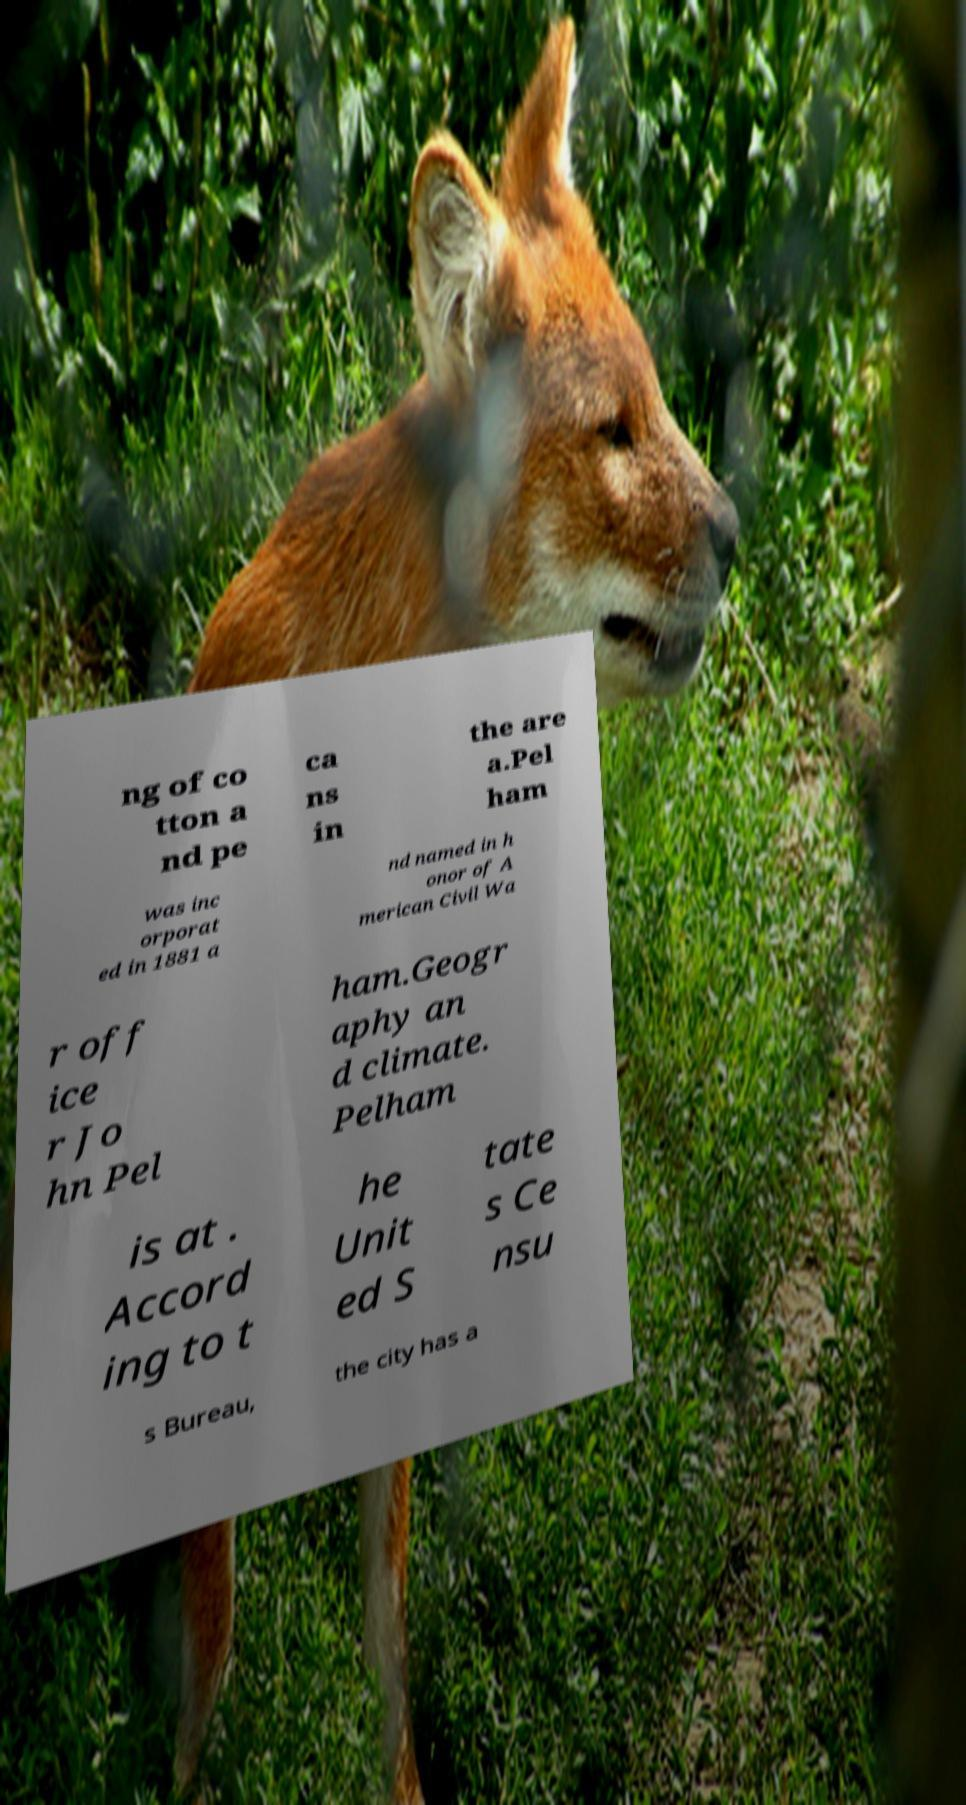I need the written content from this picture converted into text. Can you do that? ng of co tton a nd pe ca ns in the are a.Pel ham was inc orporat ed in 1881 a nd named in h onor of A merican Civil Wa r off ice r Jo hn Pel ham.Geogr aphy an d climate. Pelham is at . Accord ing to t he Unit ed S tate s Ce nsu s Bureau, the city has a 